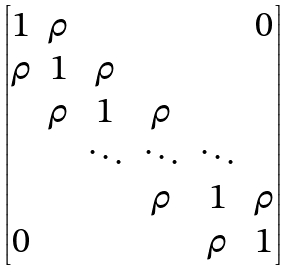<formula> <loc_0><loc_0><loc_500><loc_500>\begin{bmatrix} 1 & \rho & & & & 0 \\ \rho & 1 & \rho & & & \\ & \rho & 1 & \rho & & \\ & & \ddots & \ddots & \ddots & \\ & & & \rho & 1 & \rho \\ 0 & & & & \rho & 1 \end{bmatrix}</formula> 